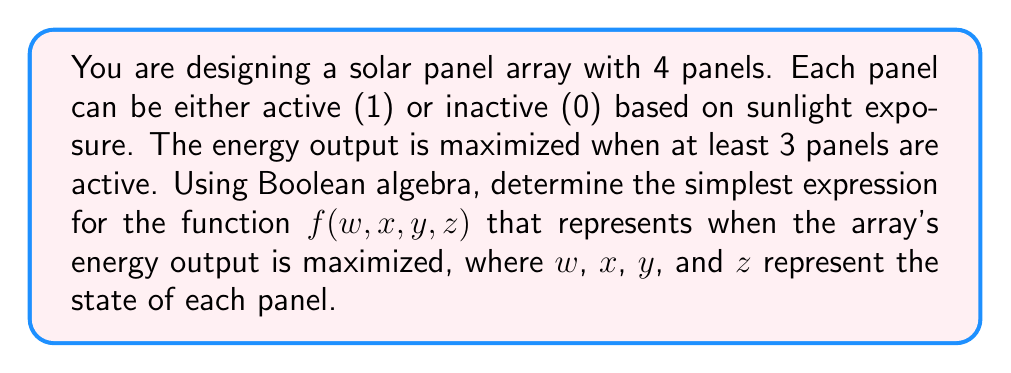Show me your answer to this math problem. 1. First, let's write out the truth table for this function. We need at least 3 panels to be active (1) for the function to be true (1).

2. The function will be true for these combinations:
   1111, 1110, 1101, 1011, 0111

3. We can write the function as a sum of minterms:

   $f(w,x,y,z) = wxyz + wxy\bar{z} + wx\bar{y}z + w\bar{x}yz + \bar{w}xyz$

4. To simplify this expression, we can use the Quine-McCluskey method or Karnaugh maps. Let's use a Karnaugh map:

   [asy]
   size(200);
   pen l = linewidth(0.5);
   for(int i=0; i<5; ++i) {
     draw((i,0)--(i,4),l);
     draw((0,i)--(4,i),l);
   }
   label("00", (0.5,3.5));
   label("01", (1.5,3.5));
   label("11", (2.5,3.5));
   label("10", (3.5,3.5));
   label("00", (-0.5,3));
   label("01", (-0.5,2));
   label("11", (-0.5,1));
   label("10", (-0.5,0));
   label("1", (2.5,1.5));
   label("1", (3.5,1.5));
   label("1", (2.5,0.5));
   label("1", (1.5,1.5));
   label("1", (2.5,2.5));
   label("yz", (2,4.5));
   label("wx", (-1.5,1.5));
   [/asy]

5. From the Karnaugh map, we can see that there are two prime implicants:
   - $wxy$ (covers 1111, 1110, 1101)
   - $xyz$ (covers 1111, 0111, 1011)

6. The simplified Boolean expression is:

   $f(w,x,y,z) = wxy + xyz$

This expression represents when at least 3 panels are active.
Answer: $f(w,x,y,z) = wxy + xyz$ 